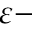Convert formula to latex. <formula><loc_0><loc_0><loc_500><loc_500>\varepsilon -</formula> 